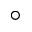<formula> <loc_0><loc_0><loc_500><loc_500>^ { \circ }</formula> 